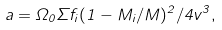Convert formula to latex. <formula><loc_0><loc_0><loc_500><loc_500>a = \Omega _ { 0 } \Sigma f _ { i } ( 1 - M _ { i } / M ) ^ { 2 } / 4 v ^ { 3 } ,</formula> 